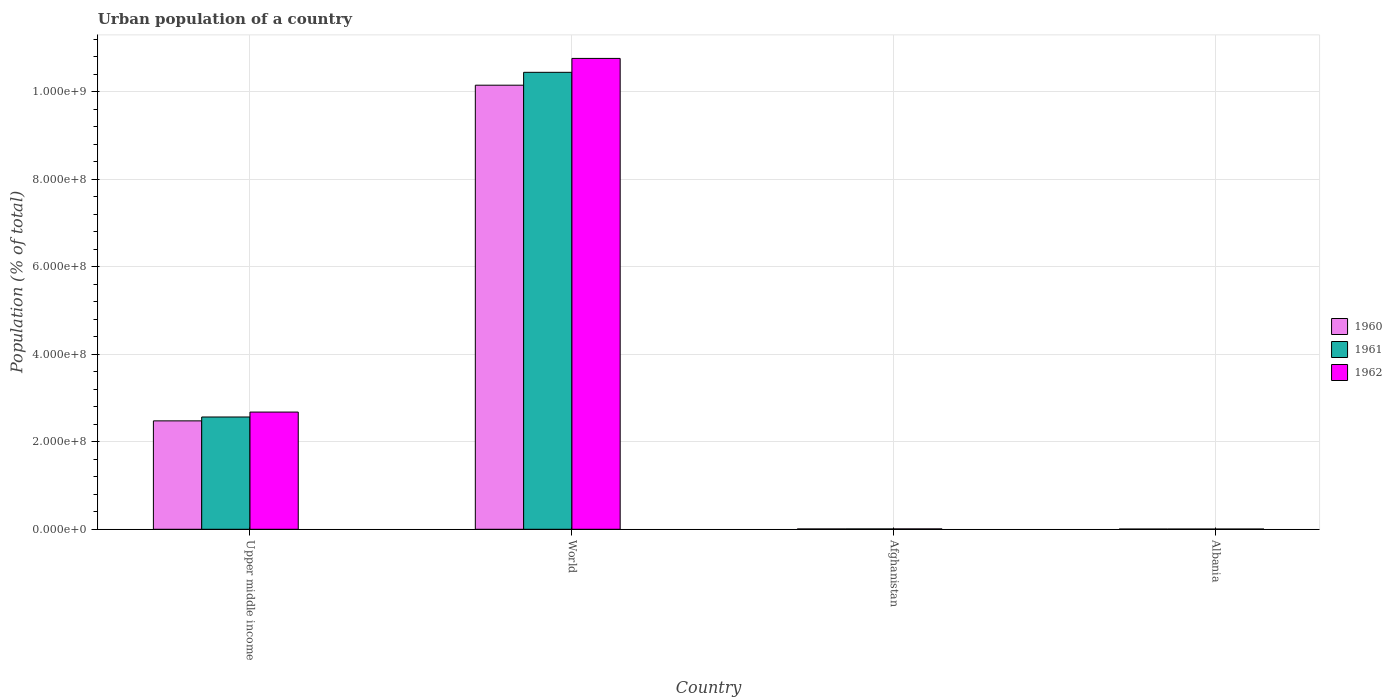How many groups of bars are there?
Make the answer very short. 4. Are the number of bars on each tick of the X-axis equal?
Offer a terse response. Yes. How many bars are there on the 4th tick from the right?
Offer a very short reply. 3. In how many cases, is the number of bars for a given country not equal to the number of legend labels?
Give a very brief answer. 0. What is the urban population in 1961 in World?
Your answer should be very brief. 1.04e+09. Across all countries, what is the maximum urban population in 1962?
Make the answer very short. 1.08e+09. Across all countries, what is the minimum urban population in 1961?
Make the answer very short. 5.14e+05. In which country was the urban population in 1961 maximum?
Offer a terse response. World. In which country was the urban population in 1961 minimum?
Keep it short and to the point. Albania. What is the total urban population in 1962 in the graph?
Give a very brief answer. 1.34e+09. What is the difference between the urban population in 1962 in Albania and that in Upper middle income?
Ensure brevity in your answer.  -2.67e+08. What is the difference between the urban population in 1960 in Upper middle income and the urban population in 1962 in Albania?
Give a very brief answer. 2.47e+08. What is the average urban population in 1960 per country?
Offer a very short reply. 3.16e+08. What is the difference between the urban population of/in 1961 and urban population of/in 1960 in Afghanistan?
Ensure brevity in your answer.  4.03e+04. In how many countries, is the urban population in 1962 greater than 440000000 %?
Your answer should be compact. 1. What is the ratio of the urban population in 1960 in Afghanistan to that in Albania?
Your response must be concise. 1.5. What is the difference between the highest and the second highest urban population in 1961?
Provide a short and direct response. -2.56e+08. What is the difference between the highest and the lowest urban population in 1960?
Your answer should be compact. 1.01e+09. What does the 1st bar from the right in World represents?
Keep it short and to the point. 1962. How many countries are there in the graph?
Ensure brevity in your answer.  4. What is the difference between two consecutive major ticks on the Y-axis?
Provide a succinct answer. 2.00e+08. How many legend labels are there?
Offer a very short reply. 3. How are the legend labels stacked?
Keep it short and to the point. Vertical. What is the title of the graph?
Give a very brief answer. Urban population of a country. Does "1998" appear as one of the legend labels in the graph?
Offer a very short reply. No. What is the label or title of the X-axis?
Offer a terse response. Country. What is the label or title of the Y-axis?
Your answer should be compact. Population (% of total). What is the Population (% of total) of 1960 in Upper middle income?
Offer a terse response. 2.48e+08. What is the Population (% of total) in 1961 in Upper middle income?
Your answer should be very brief. 2.57e+08. What is the Population (% of total) of 1962 in Upper middle income?
Keep it short and to the point. 2.68e+08. What is the Population (% of total) of 1960 in World?
Offer a very short reply. 1.01e+09. What is the Population (% of total) in 1961 in World?
Ensure brevity in your answer.  1.04e+09. What is the Population (% of total) of 1962 in World?
Ensure brevity in your answer.  1.08e+09. What is the Population (% of total) of 1960 in Afghanistan?
Offer a terse response. 7.39e+05. What is the Population (% of total) in 1961 in Afghanistan?
Your answer should be compact. 7.80e+05. What is the Population (% of total) in 1962 in Afghanistan?
Your response must be concise. 8.23e+05. What is the Population (% of total) in 1960 in Albania?
Provide a succinct answer. 4.94e+05. What is the Population (% of total) in 1961 in Albania?
Your answer should be very brief. 5.14e+05. What is the Population (% of total) in 1962 in Albania?
Your answer should be compact. 5.31e+05. Across all countries, what is the maximum Population (% of total) in 1960?
Provide a succinct answer. 1.01e+09. Across all countries, what is the maximum Population (% of total) of 1961?
Provide a succinct answer. 1.04e+09. Across all countries, what is the maximum Population (% of total) in 1962?
Provide a succinct answer. 1.08e+09. Across all countries, what is the minimum Population (% of total) in 1960?
Keep it short and to the point. 4.94e+05. Across all countries, what is the minimum Population (% of total) of 1961?
Make the answer very short. 5.14e+05. Across all countries, what is the minimum Population (% of total) of 1962?
Offer a terse response. 5.31e+05. What is the total Population (% of total) in 1960 in the graph?
Offer a very short reply. 1.26e+09. What is the total Population (% of total) of 1961 in the graph?
Keep it short and to the point. 1.30e+09. What is the total Population (% of total) in 1962 in the graph?
Your answer should be very brief. 1.34e+09. What is the difference between the Population (% of total) of 1960 in Upper middle income and that in World?
Offer a very short reply. -7.67e+08. What is the difference between the Population (% of total) in 1961 in Upper middle income and that in World?
Provide a succinct answer. -7.88e+08. What is the difference between the Population (% of total) of 1962 in Upper middle income and that in World?
Make the answer very short. -8.08e+08. What is the difference between the Population (% of total) of 1960 in Upper middle income and that in Afghanistan?
Give a very brief answer. 2.47e+08. What is the difference between the Population (% of total) of 1961 in Upper middle income and that in Afghanistan?
Provide a short and direct response. 2.56e+08. What is the difference between the Population (% of total) in 1962 in Upper middle income and that in Afghanistan?
Offer a terse response. 2.67e+08. What is the difference between the Population (% of total) in 1960 in Upper middle income and that in Albania?
Provide a short and direct response. 2.47e+08. What is the difference between the Population (% of total) in 1961 in Upper middle income and that in Albania?
Offer a terse response. 2.56e+08. What is the difference between the Population (% of total) of 1962 in Upper middle income and that in Albania?
Your answer should be very brief. 2.67e+08. What is the difference between the Population (% of total) in 1960 in World and that in Afghanistan?
Make the answer very short. 1.01e+09. What is the difference between the Population (% of total) of 1961 in World and that in Afghanistan?
Keep it short and to the point. 1.04e+09. What is the difference between the Population (% of total) of 1962 in World and that in Afghanistan?
Provide a short and direct response. 1.07e+09. What is the difference between the Population (% of total) in 1960 in World and that in Albania?
Keep it short and to the point. 1.01e+09. What is the difference between the Population (% of total) of 1961 in World and that in Albania?
Provide a succinct answer. 1.04e+09. What is the difference between the Population (% of total) in 1962 in World and that in Albania?
Give a very brief answer. 1.08e+09. What is the difference between the Population (% of total) of 1960 in Afghanistan and that in Albania?
Offer a terse response. 2.45e+05. What is the difference between the Population (% of total) in 1961 in Afghanistan and that in Albania?
Offer a terse response. 2.66e+05. What is the difference between the Population (% of total) in 1962 in Afghanistan and that in Albania?
Your response must be concise. 2.92e+05. What is the difference between the Population (% of total) in 1960 in Upper middle income and the Population (% of total) in 1961 in World?
Give a very brief answer. -7.96e+08. What is the difference between the Population (% of total) of 1960 in Upper middle income and the Population (% of total) of 1962 in World?
Your answer should be compact. -8.28e+08. What is the difference between the Population (% of total) in 1961 in Upper middle income and the Population (% of total) in 1962 in World?
Your answer should be compact. -8.19e+08. What is the difference between the Population (% of total) of 1960 in Upper middle income and the Population (% of total) of 1961 in Afghanistan?
Make the answer very short. 2.47e+08. What is the difference between the Population (% of total) of 1960 in Upper middle income and the Population (% of total) of 1962 in Afghanistan?
Provide a short and direct response. 2.47e+08. What is the difference between the Population (% of total) of 1961 in Upper middle income and the Population (% of total) of 1962 in Afghanistan?
Provide a succinct answer. 2.56e+08. What is the difference between the Population (% of total) in 1960 in Upper middle income and the Population (% of total) in 1961 in Albania?
Make the answer very short. 2.47e+08. What is the difference between the Population (% of total) of 1960 in Upper middle income and the Population (% of total) of 1962 in Albania?
Provide a succinct answer. 2.47e+08. What is the difference between the Population (% of total) of 1961 in Upper middle income and the Population (% of total) of 1962 in Albania?
Your answer should be very brief. 2.56e+08. What is the difference between the Population (% of total) in 1960 in World and the Population (% of total) in 1961 in Afghanistan?
Provide a succinct answer. 1.01e+09. What is the difference between the Population (% of total) of 1960 in World and the Population (% of total) of 1962 in Afghanistan?
Offer a terse response. 1.01e+09. What is the difference between the Population (% of total) of 1961 in World and the Population (% of total) of 1962 in Afghanistan?
Provide a succinct answer. 1.04e+09. What is the difference between the Population (% of total) of 1960 in World and the Population (% of total) of 1961 in Albania?
Your answer should be compact. 1.01e+09. What is the difference between the Population (% of total) of 1960 in World and the Population (% of total) of 1962 in Albania?
Your answer should be compact. 1.01e+09. What is the difference between the Population (% of total) of 1961 in World and the Population (% of total) of 1962 in Albania?
Offer a very short reply. 1.04e+09. What is the difference between the Population (% of total) of 1960 in Afghanistan and the Population (% of total) of 1961 in Albania?
Provide a succinct answer. 2.26e+05. What is the difference between the Population (% of total) of 1960 in Afghanistan and the Population (% of total) of 1962 in Albania?
Provide a short and direct response. 2.09e+05. What is the difference between the Population (% of total) in 1961 in Afghanistan and the Population (% of total) in 1962 in Albania?
Your answer should be very brief. 2.49e+05. What is the average Population (% of total) of 1960 per country?
Offer a terse response. 3.16e+08. What is the average Population (% of total) in 1961 per country?
Keep it short and to the point. 3.25e+08. What is the average Population (% of total) of 1962 per country?
Your answer should be very brief. 3.36e+08. What is the difference between the Population (% of total) of 1960 and Population (% of total) of 1961 in Upper middle income?
Provide a short and direct response. -8.85e+06. What is the difference between the Population (% of total) in 1960 and Population (% of total) in 1962 in Upper middle income?
Keep it short and to the point. -2.01e+07. What is the difference between the Population (% of total) in 1961 and Population (% of total) in 1962 in Upper middle income?
Provide a short and direct response. -1.13e+07. What is the difference between the Population (% of total) of 1960 and Population (% of total) of 1961 in World?
Provide a short and direct response. -2.94e+07. What is the difference between the Population (% of total) of 1960 and Population (% of total) of 1962 in World?
Offer a very short reply. -6.12e+07. What is the difference between the Population (% of total) in 1961 and Population (% of total) in 1962 in World?
Your answer should be very brief. -3.17e+07. What is the difference between the Population (% of total) in 1960 and Population (% of total) in 1961 in Afghanistan?
Offer a terse response. -4.03e+04. What is the difference between the Population (% of total) in 1960 and Population (% of total) in 1962 in Afghanistan?
Keep it short and to the point. -8.33e+04. What is the difference between the Population (% of total) of 1961 and Population (% of total) of 1962 in Afghanistan?
Ensure brevity in your answer.  -4.30e+04. What is the difference between the Population (% of total) in 1960 and Population (% of total) in 1961 in Albania?
Your answer should be very brief. -1.96e+04. What is the difference between the Population (% of total) of 1960 and Population (% of total) of 1962 in Albania?
Ensure brevity in your answer.  -3.68e+04. What is the difference between the Population (% of total) of 1961 and Population (% of total) of 1962 in Albania?
Make the answer very short. -1.72e+04. What is the ratio of the Population (% of total) of 1960 in Upper middle income to that in World?
Your answer should be compact. 0.24. What is the ratio of the Population (% of total) in 1961 in Upper middle income to that in World?
Ensure brevity in your answer.  0.25. What is the ratio of the Population (% of total) in 1962 in Upper middle income to that in World?
Offer a terse response. 0.25. What is the ratio of the Population (% of total) in 1960 in Upper middle income to that in Afghanistan?
Make the answer very short. 334.93. What is the ratio of the Population (% of total) in 1961 in Upper middle income to that in Afghanistan?
Your answer should be very brief. 328.97. What is the ratio of the Population (% of total) in 1962 in Upper middle income to that in Afghanistan?
Keep it short and to the point. 325.48. What is the ratio of the Population (% of total) of 1960 in Upper middle income to that in Albania?
Give a very brief answer. 501.37. What is the ratio of the Population (% of total) of 1961 in Upper middle income to that in Albania?
Ensure brevity in your answer.  499.46. What is the ratio of the Population (% of total) of 1962 in Upper middle income to that in Albania?
Provide a succinct answer. 504.51. What is the ratio of the Population (% of total) in 1960 in World to that in Afghanistan?
Your answer should be compact. 1372.06. What is the ratio of the Population (% of total) of 1961 in World to that in Afghanistan?
Offer a very short reply. 1338.91. What is the ratio of the Population (% of total) in 1962 in World to that in Afghanistan?
Your response must be concise. 1307.58. What is the ratio of the Population (% of total) in 1960 in World to that in Albania?
Give a very brief answer. 2053.89. What is the ratio of the Population (% of total) of 1961 in World to that in Albania?
Give a very brief answer. 2032.78. What is the ratio of the Population (% of total) in 1962 in World to that in Albania?
Offer a terse response. 2026.82. What is the ratio of the Population (% of total) in 1960 in Afghanistan to that in Albania?
Offer a terse response. 1.5. What is the ratio of the Population (% of total) of 1961 in Afghanistan to that in Albania?
Keep it short and to the point. 1.52. What is the ratio of the Population (% of total) in 1962 in Afghanistan to that in Albania?
Keep it short and to the point. 1.55. What is the difference between the highest and the second highest Population (% of total) in 1960?
Ensure brevity in your answer.  7.67e+08. What is the difference between the highest and the second highest Population (% of total) in 1961?
Keep it short and to the point. 7.88e+08. What is the difference between the highest and the second highest Population (% of total) of 1962?
Ensure brevity in your answer.  8.08e+08. What is the difference between the highest and the lowest Population (% of total) in 1960?
Offer a terse response. 1.01e+09. What is the difference between the highest and the lowest Population (% of total) of 1961?
Your answer should be compact. 1.04e+09. What is the difference between the highest and the lowest Population (% of total) of 1962?
Give a very brief answer. 1.08e+09. 